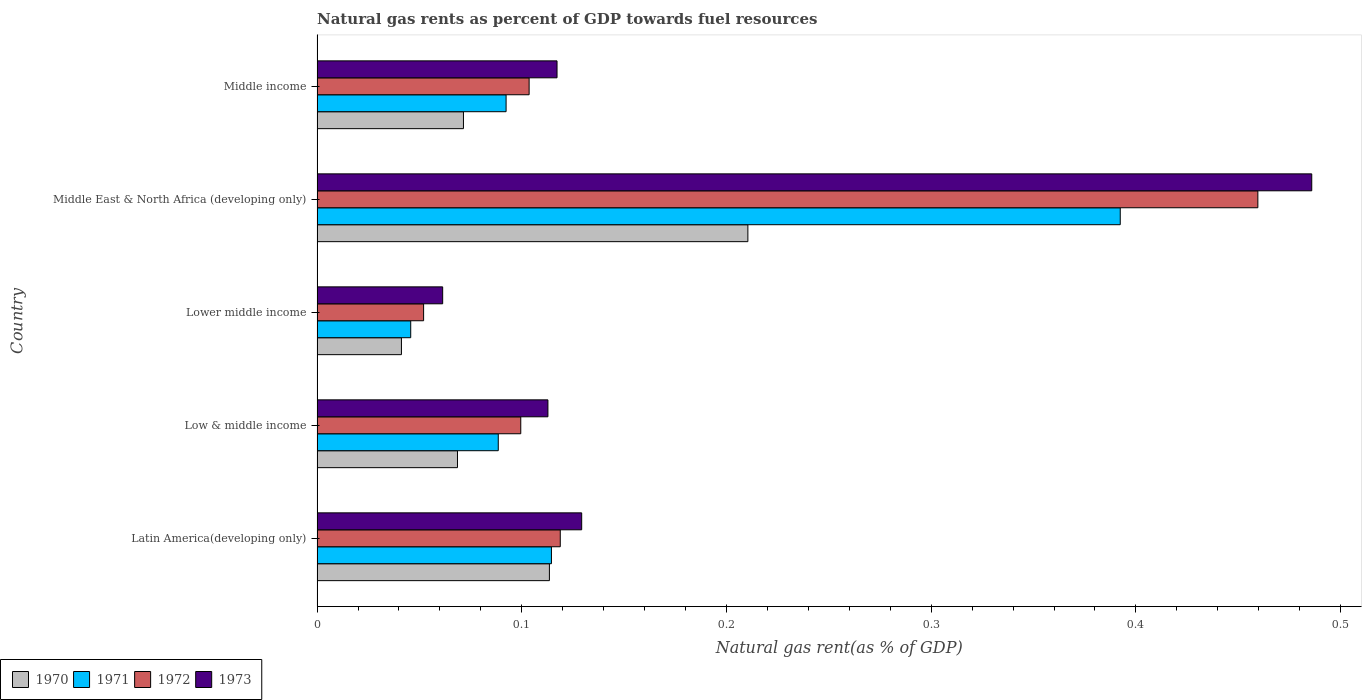How many different coloured bars are there?
Provide a succinct answer. 4. Are the number of bars per tick equal to the number of legend labels?
Make the answer very short. Yes. What is the label of the 2nd group of bars from the top?
Your answer should be compact. Middle East & North Africa (developing only). What is the natural gas rent in 1971 in Middle income?
Ensure brevity in your answer.  0.09. Across all countries, what is the maximum natural gas rent in 1972?
Your answer should be very brief. 0.46. Across all countries, what is the minimum natural gas rent in 1970?
Ensure brevity in your answer.  0.04. In which country was the natural gas rent in 1973 maximum?
Your answer should be compact. Middle East & North Africa (developing only). In which country was the natural gas rent in 1971 minimum?
Offer a terse response. Lower middle income. What is the total natural gas rent in 1973 in the graph?
Give a very brief answer. 0.91. What is the difference between the natural gas rent in 1972 in Latin America(developing only) and that in Lower middle income?
Make the answer very short. 0.07. What is the difference between the natural gas rent in 1973 in Lower middle income and the natural gas rent in 1972 in Low & middle income?
Provide a short and direct response. -0.04. What is the average natural gas rent in 1973 per country?
Provide a short and direct response. 0.18. What is the difference between the natural gas rent in 1972 and natural gas rent in 1971 in Low & middle income?
Provide a succinct answer. 0.01. In how many countries, is the natural gas rent in 1972 greater than 0.2 %?
Your answer should be very brief. 1. What is the ratio of the natural gas rent in 1972 in Middle East & North Africa (developing only) to that in Middle income?
Provide a succinct answer. 4.44. Is the difference between the natural gas rent in 1972 in Low & middle income and Middle income greater than the difference between the natural gas rent in 1971 in Low & middle income and Middle income?
Your answer should be compact. No. What is the difference between the highest and the second highest natural gas rent in 1971?
Make the answer very short. 0.28. What is the difference between the highest and the lowest natural gas rent in 1972?
Make the answer very short. 0.41. Is the sum of the natural gas rent in 1973 in Low & middle income and Middle income greater than the maximum natural gas rent in 1972 across all countries?
Provide a short and direct response. No. Is it the case that in every country, the sum of the natural gas rent in 1972 and natural gas rent in 1973 is greater than the sum of natural gas rent in 1970 and natural gas rent in 1971?
Ensure brevity in your answer.  No. What does the 4th bar from the top in Lower middle income represents?
Provide a short and direct response. 1970. Is it the case that in every country, the sum of the natural gas rent in 1973 and natural gas rent in 1970 is greater than the natural gas rent in 1972?
Your response must be concise. Yes. Are all the bars in the graph horizontal?
Ensure brevity in your answer.  Yes. Does the graph contain grids?
Give a very brief answer. No. What is the title of the graph?
Your answer should be very brief. Natural gas rents as percent of GDP towards fuel resources. Does "1962" appear as one of the legend labels in the graph?
Make the answer very short. No. What is the label or title of the X-axis?
Provide a short and direct response. Natural gas rent(as % of GDP). What is the label or title of the Y-axis?
Provide a succinct answer. Country. What is the Natural gas rent(as % of GDP) of 1970 in Latin America(developing only)?
Your response must be concise. 0.11. What is the Natural gas rent(as % of GDP) of 1971 in Latin America(developing only)?
Provide a short and direct response. 0.11. What is the Natural gas rent(as % of GDP) in 1972 in Latin America(developing only)?
Give a very brief answer. 0.12. What is the Natural gas rent(as % of GDP) of 1973 in Latin America(developing only)?
Provide a succinct answer. 0.13. What is the Natural gas rent(as % of GDP) of 1970 in Low & middle income?
Offer a very short reply. 0.07. What is the Natural gas rent(as % of GDP) of 1971 in Low & middle income?
Your answer should be very brief. 0.09. What is the Natural gas rent(as % of GDP) of 1972 in Low & middle income?
Provide a succinct answer. 0.1. What is the Natural gas rent(as % of GDP) in 1973 in Low & middle income?
Give a very brief answer. 0.11. What is the Natural gas rent(as % of GDP) in 1970 in Lower middle income?
Provide a succinct answer. 0.04. What is the Natural gas rent(as % of GDP) in 1971 in Lower middle income?
Keep it short and to the point. 0.05. What is the Natural gas rent(as % of GDP) of 1972 in Lower middle income?
Your answer should be very brief. 0.05. What is the Natural gas rent(as % of GDP) in 1973 in Lower middle income?
Your answer should be very brief. 0.06. What is the Natural gas rent(as % of GDP) of 1970 in Middle East & North Africa (developing only)?
Offer a very short reply. 0.21. What is the Natural gas rent(as % of GDP) in 1971 in Middle East & North Africa (developing only)?
Offer a terse response. 0.39. What is the Natural gas rent(as % of GDP) in 1972 in Middle East & North Africa (developing only)?
Your answer should be compact. 0.46. What is the Natural gas rent(as % of GDP) of 1973 in Middle East & North Africa (developing only)?
Your answer should be compact. 0.49. What is the Natural gas rent(as % of GDP) of 1970 in Middle income?
Provide a succinct answer. 0.07. What is the Natural gas rent(as % of GDP) of 1971 in Middle income?
Provide a short and direct response. 0.09. What is the Natural gas rent(as % of GDP) in 1972 in Middle income?
Your answer should be very brief. 0.1. What is the Natural gas rent(as % of GDP) in 1973 in Middle income?
Offer a terse response. 0.12. Across all countries, what is the maximum Natural gas rent(as % of GDP) of 1970?
Provide a short and direct response. 0.21. Across all countries, what is the maximum Natural gas rent(as % of GDP) in 1971?
Provide a short and direct response. 0.39. Across all countries, what is the maximum Natural gas rent(as % of GDP) in 1972?
Keep it short and to the point. 0.46. Across all countries, what is the maximum Natural gas rent(as % of GDP) in 1973?
Ensure brevity in your answer.  0.49. Across all countries, what is the minimum Natural gas rent(as % of GDP) of 1970?
Offer a terse response. 0.04. Across all countries, what is the minimum Natural gas rent(as % of GDP) of 1971?
Offer a very short reply. 0.05. Across all countries, what is the minimum Natural gas rent(as % of GDP) in 1972?
Make the answer very short. 0.05. Across all countries, what is the minimum Natural gas rent(as % of GDP) of 1973?
Give a very brief answer. 0.06. What is the total Natural gas rent(as % of GDP) of 1970 in the graph?
Keep it short and to the point. 0.51. What is the total Natural gas rent(as % of GDP) in 1971 in the graph?
Keep it short and to the point. 0.73. What is the total Natural gas rent(as % of GDP) in 1972 in the graph?
Your answer should be compact. 0.83. What is the total Natural gas rent(as % of GDP) in 1973 in the graph?
Make the answer very short. 0.91. What is the difference between the Natural gas rent(as % of GDP) in 1970 in Latin America(developing only) and that in Low & middle income?
Make the answer very short. 0.04. What is the difference between the Natural gas rent(as % of GDP) in 1971 in Latin America(developing only) and that in Low & middle income?
Keep it short and to the point. 0.03. What is the difference between the Natural gas rent(as % of GDP) of 1972 in Latin America(developing only) and that in Low & middle income?
Your response must be concise. 0.02. What is the difference between the Natural gas rent(as % of GDP) of 1973 in Latin America(developing only) and that in Low & middle income?
Your answer should be very brief. 0.02. What is the difference between the Natural gas rent(as % of GDP) of 1970 in Latin America(developing only) and that in Lower middle income?
Your response must be concise. 0.07. What is the difference between the Natural gas rent(as % of GDP) in 1971 in Latin America(developing only) and that in Lower middle income?
Your answer should be very brief. 0.07. What is the difference between the Natural gas rent(as % of GDP) in 1972 in Latin America(developing only) and that in Lower middle income?
Offer a very short reply. 0.07. What is the difference between the Natural gas rent(as % of GDP) in 1973 in Latin America(developing only) and that in Lower middle income?
Give a very brief answer. 0.07. What is the difference between the Natural gas rent(as % of GDP) in 1970 in Latin America(developing only) and that in Middle East & North Africa (developing only)?
Offer a very short reply. -0.1. What is the difference between the Natural gas rent(as % of GDP) of 1971 in Latin America(developing only) and that in Middle East & North Africa (developing only)?
Offer a terse response. -0.28. What is the difference between the Natural gas rent(as % of GDP) of 1972 in Latin America(developing only) and that in Middle East & North Africa (developing only)?
Your response must be concise. -0.34. What is the difference between the Natural gas rent(as % of GDP) of 1973 in Latin America(developing only) and that in Middle East & North Africa (developing only)?
Your answer should be very brief. -0.36. What is the difference between the Natural gas rent(as % of GDP) of 1970 in Latin America(developing only) and that in Middle income?
Your response must be concise. 0.04. What is the difference between the Natural gas rent(as % of GDP) of 1971 in Latin America(developing only) and that in Middle income?
Your response must be concise. 0.02. What is the difference between the Natural gas rent(as % of GDP) of 1972 in Latin America(developing only) and that in Middle income?
Provide a short and direct response. 0.02. What is the difference between the Natural gas rent(as % of GDP) of 1973 in Latin America(developing only) and that in Middle income?
Give a very brief answer. 0.01. What is the difference between the Natural gas rent(as % of GDP) in 1970 in Low & middle income and that in Lower middle income?
Ensure brevity in your answer.  0.03. What is the difference between the Natural gas rent(as % of GDP) of 1971 in Low & middle income and that in Lower middle income?
Your response must be concise. 0.04. What is the difference between the Natural gas rent(as % of GDP) in 1972 in Low & middle income and that in Lower middle income?
Offer a terse response. 0.05. What is the difference between the Natural gas rent(as % of GDP) of 1973 in Low & middle income and that in Lower middle income?
Ensure brevity in your answer.  0.05. What is the difference between the Natural gas rent(as % of GDP) in 1970 in Low & middle income and that in Middle East & North Africa (developing only)?
Keep it short and to the point. -0.14. What is the difference between the Natural gas rent(as % of GDP) of 1971 in Low & middle income and that in Middle East & North Africa (developing only)?
Make the answer very short. -0.3. What is the difference between the Natural gas rent(as % of GDP) in 1972 in Low & middle income and that in Middle East & North Africa (developing only)?
Ensure brevity in your answer.  -0.36. What is the difference between the Natural gas rent(as % of GDP) of 1973 in Low & middle income and that in Middle East & North Africa (developing only)?
Offer a very short reply. -0.37. What is the difference between the Natural gas rent(as % of GDP) in 1970 in Low & middle income and that in Middle income?
Offer a terse response. -0. What is the difference between the Natural gas rent(as % of GDP) in 1971 in Low & middle income and that in Middle income?
Your answer should be very brief. -0. What is the difference between the Natural gas rent(as % of GDP) in 1972 in Low & middle income and that in Middle income?
Provide a short and direct response. -0. What is the difference between the Natural gas rent(as % of GDP) of 1973 in Low & middle income and that in Middle income?
Make the answer very short. -0. What is the difference between the Natural gas rent(as % of GDP) of 1970 in Lower middle income and that in Middle East & North Africa (developing only)?
Keep it short and to the point. -0.17. What is the difference between the Natural gas rent(as % of GDP) of 1971 in Lower middle income and that in Middle East & North Africa (developing only)?
Keep it short and to the point. -0.35. What is the difference between the Natural gas rent(as % of GDP) in 1972 in Lower middle income and that in Middle East & North Africa (developing only)?
Provide a succinct answer. -0.41. What is the difference between the Natural gas rent(as % of GDP) in 1973 in Lower middle income and that in Middle East & North Africa (developing only)?
Provide a short and direct response. -0.42. What is the difference between the Natural gas rent(as % of GDP) of 1970 in Lower middle income and that in Middle income?
Provide a short and direct response. -0.03. What is the difference between the Natural gas rent(as % of GDP) of 1971 in Lower middle income and that in Middle income?
Give a very brief answer. -0.05. What is the difference between the Natural gas rent(as % of GDP) of 1972 in Lower middle income and that in Middle income?
Give a very brief answer. -0.05. What is the difference between the Natural gas rent(as % of GDP) of 1973 in Lower middle income and that in Middle income?
Ensure brevity in your answer.  -0.06. What is the difference between the Natural gas rent(as % of GDP) of 1970 in Middle East & North Africa (developing only) and that in Middle income?
Offer a very short reply. 0.14. What is the difference between the Natural gas rent(as % of GDP) in 1972 in Middle East & North Africa (developing only) and that in Middle income?
Provide a succinct answer. 0.36. What is the difference between the Natural gas rent(as % of GDP) in 1973 in Middle East & North Africa (developing only) and that in Middle income?
Your answer should be compact. 0.37. What is the difference between the Natural gas rent(as % of GDP) in 1970 in Latin America(developing only) and the Natural gas rent(as % of GDP) in 1971 in Low & middle income?
Make the answer very short. 0.03. What is the difference between the Natural gas rent(as % of GDP) in 1970 in Latin America(developing only) and the Natural gas rent(as % of GDP) in 1972 in Low & middle income?
Offer a very short reply. 0.01. What is the difference between the Natural gas rent(as % of GDP) in 1970 in Latin America(developing only) and the Natural gas rent(as % of GDP) in 1973 in Low & middle income?
Offer a terse response. 0. What is the difference between the Natural gas rent(as % of GDP) in 1971 in Latin America(developing only) and the Natural gas rent(as % of GDP) in 1972 in Low & middle income?
Give a very brief answer. 0.01. What is the difference between the Natural gas rent(as % of GDP) in 1971 in Latin America(developing only) and the Natural gas rent(as % of GDP) in 1973 in Low & middle income?
Keep it short and to the point. 0. What is the difference between the Natural gas rent(as % of GDP) in 1972 in Latin America(developing only) and the Natural gas rent(as % of GDP) in 1973 in Low & middle income?
Your answer should be very brief. 0.01. What is the difference between the Natural gas rent(as % of GDP) of 1970 in Latin America(developing only) and the Natural gas rent(as % of GDP) of 1971 in Lower middle income?
Offer a terse response. 0.07. What is the difference between the Natural gas rent(as % of GDP) in 1970 in Latin America(developing only) and the Natural gas rent(as % of GDP) in 1972 in Lower middle income?
Your answer should be compact. 0.06. What is the difference between the Natural gas rent(as % of GDP) in 1970 in Latin America(developing only) and the Natural gas rent(as % of GDP) in 1973 in Lower middle income?
Provide a succinct answer. 0.05. What is the difference between the Natural gas rent(as % of GDP) in 1971 in Latin America(developing only) and the Natural gas rent(as % of GDP) in 1972 in Lower middle income?
Your answer should be very brief. 0.06. What is the difference between the Natural gas rent(as % of GDP) in 1971 in Latin America(developing only) and the Natural gas rent(as % of GDP) in 1973 in Lower middle income?
Your answer should be very brief. 0.05. What is the difference between the Natural gas rent(as % of GDP) in 1972 in Latin America(developing only) and the Natural gas rent(as % of GDP) in 1973 in Lower middle income?
Give a very brief answer. 0.06. What is the difference between the Natural gas rent(as % of GDP) in 1970 in Latin America(developing only) and the Natural gas rent(as % of GDP) in 1971 in Middle East & North Africa (developing only)?
Your response must be concise. -0.28. What is the difference between the Natural gas rent(as % of GDP) in 1970 in Latin America(developing only) and the Natural gas rent(as % of GDP) in 1972 in Middle East & North Africa (developing only)?
Provide a short and direct response. -0.35. What is the difference between the Natural gas rent(as % of GDP) in 1970 in Latin America(developing only) and the Natural gas rent(as % of GDP) in 1973 in Middle East & North Africa (developing only)?
Provide a succinct answer. -0.37. What is the difference between the Natural gas rent(as % of GDP) of 1971 in Latin America(developing only) and the Natural gas rent(as % of GDP) of 1972 in Middle East & North Africa (developing only)?
Keep it short and to the point. -0.35. What is the difference between the Natural gas rent(as % of GDP) in 1971 in Latin America(developing only) and the Natural gas rent(as % of GDP) in 1973 in Middle East & North Africa (developing only)?
Keep it short and to the point. -0.37. What is the difference between the Natural gas rent(as % of GDP) of 1972 in Latin America(developing only) and the Natural gas rent(as % of GDP) of 1973 in Middle East & North Africa (developing only)?
Ensure brevity in your answer.  -0.37. What is the difference between the Natural gas rent(as % of GDP) of 1970 in Latin America(developing only) and the Natural gas rent(as % of GDP) of 1971 in Middle income?
Provide a short and direct response. 0.02. What is the difference between the Natural gas rent(as % of GDP) in 1970 in Latin America(developing only) and the Natural gas rent(as % of GDP) in 1972 in Middle income?
Offer a very short reply. 0.01. What is the difference between the Natural gas rent(as % of GDP) in 1970 in Latin America(developing only) and the Natural gas rent(as % of GDP) in 1973 in Middle income?
Give a very brief answer. -0. What is the difference between the Natural gas rent(as % of GDP) in 1971 in Latin America(developing only) and the Natural gas rent(as % of GDP) in 1972 in Middle income?
Provide a succinct answer. 0.01. What is the difference between the Natural gas rent(as % of GDP) of 1971 in Latin America(developing only) and the Natural gas rent(as % of GDP) of 1973 in Middle income?
Offer a very short reply. -0. What is the difference between the Natural gas rent(as % of GDP) of 1972 in Latin America(developing only) and the Natural gas rent(as % of GDP) of 1973 in Middle income?
Offer a very short reply. 0. What is the difference between the Natural gas rent(as % of GDP) of 1970 in Low & middle income and the Natural gas rent(as % of GDP) of 1971 in Lower middle income?
Ensure brevity in your answer.  0.02. What is the difference between the Natural gas rent(as % of GDP) in 1970 in Low & middle income and the Natural gas rent(as % of GDP) in 1972 in Lower middle income?
Provide a short and direct response. 0.02. What is the difference between the Natural gas rent(as % of GDP) of 1970 in Low & middle income and the Natural gas rent(as % of GDP) of 1973 in Lower middle income?
Give a very brief answer. 0.01. What is the difference between the Natural gas rent(as % of GDP) in 1971 in Low & middle income and the Natural gas rent(as % of GDP) in 1972 in Lower middle income?
Keep it short and to the point. 0.04. What is the difference between the Natural gas rent(as % of GDP) of 1971 in Low & middle income and the Natural gas rent(as % of GDP) of 1973 in Lower middle income?
Your response must be concise. 0.03. What is the difference between the Natural gas rent(as % of GDP) in 1972 in Low & middle income and the Natural gas rent(as % of GDP) in 1973 in Lower middle income?
Offer a very short reply. 0.04. What is the difference between the Natural gas rent(as % of GDP) in 1970 in Low & middle income and the Natural gas rent(as % of GDP) in 1971 in Middle East & North Africa (developing only)?
Offer a very short reply. -0.32. What is the difference between the Natural gas rent(as % of GDP) of 1970 in Low & middle income and the Natural gas rent(as % of GDP) of 1972 in Middle East & North Africa (developing only)?
Offer a terse response. -0.39. What is the difference between the Natural gas rent(as % of GDP) in 1970 in Low & middle income and the Natural gas rent(as % of GDP) in 1973 in Middle East & North Africa (developing only)?
Ensure brevity in your answer.  -0.42. What is the difference between the Natural gas rent(as % of GDP) of 1971 in Low & middle income and the Natural gas rent(as % of GDP) of 1972 in Middle East & North Africa (developing only)?
Your response must be concise. -0.37. What is the difference between the Natural gas rent(as % of GDP) in 1971 in Low & middle income and the Natural gas rent(as % of GDP) in 1973 in Middle East & North Africa (developing only)?
Make the answer very short. -0.4. What is the difference between the Natural gas rent(as % of GDP) in 1972 in Low & middle income and the Natural gas rent(as % of GDP) in 1973 in Middle East & North Africa (developing only)?
Offer a very short reply. -0.39. What is the difference between the Natural gas rent(as % of GDP) of 1970 in Low & middle income and the Natural gas rent(as % of GDP) of 1971 in Middle income?
Give a very brief answer. -0.02. What is the difference between the Natural gas rent(as % of GDP) in 1970 in Low & middle income and the Natural gas rent(as % of GDP) in 1972 in Middle income?
Ensure brevity in your answer.  -0.04. What is the difference between the Natural gas rent(as % of GDP) in 1970 in Low & middle income and the Natural gas rent(as % of GDP) in 1973 in Middle income?
Make the answer very short. -0.05. What is the difference between the Natural gas rent(as % of GDP) in 1971 in Low & middle income and the Natural gas rent(as % of GDP) in 1972 in Middle income?
Offer a terse response. -0.02. What is the difference between the Natural gas rent(as % of GDP) in 1971 in Low & middle income and the Natural gas rent(as % of GDP) in 1973 in Middle income?
Provide a short and direct response. -0.03. What is the difference between the Natural gas rent(as % of GDP) of 1972 in Low & middle income and the Natural gas rent(as % of GDP) of 1973 in Middle income?
Give a very brief answer. -0.02. What is the difference between the Natural gas rent(as % of GDP) in 1970 in Lower middle income and the Natural gas rent(as % of GDP) in 1971 in Middle East & North Africa (developing only)?
Your answer should be very brief. -0.35. What is the difference between the Natural gas rent(as % of GDP) in 1970 in Lower middle income and the Natural gas rent(as % of GDP) in 1972 in Middle East & North Africa (developing only)?
Provide a short and direct response. -0.42. What is the difference between the Natural gas rent(as % of GDP) of 1970 in Lower middle income and the Natural gas rent(as % of GDP) of 1973 in Middle East & North Africa (developing only)?
Offer a very short reply. -0.44. What is the difference between the Natural gas rent(as % of GDP) in 1971 in Lower middle income and the Natural gas rent(as % of GDP) in 1972 in Middle East & North Africa (developing only)?
Give a very brief answer. -0.41. What is the difference between the Natural gas rent(as % of GDP) in 1971 in Lower middle income and the Natural gas rent(as % of GDP) in 1973 in Middle East & North Africa (developing only)?
Your response must be concise. -0.44. What is the difference between the Natural gas rent(as % of GDP) in 1972 in Lower middle income and the Natural gas rent(as % of GDP) in 1973 in Middle East & North Africa (developing only)?
Your answer should be compact. -0.43. What is the difference between the Natural gas rent(as % of GDP) in 1970 in Lower middle income and the Natural gas rent(as % of GDP) in 1971 in Middle income?
Provide a short and direct response. -0.05. What is the difference between the Natural gas rent(as % of GDP) of 1970 in Lower middle income and the Natural gas rent(as % of GDP) of 1972 in Middle income?
Your answer should be very brief. -0.06. What is the difference between the Natural gas rent(as % of GDP) in 1970 in Lower middle income and the Natural gas rent(as % of GDP) in 1973 in Middle income?
Your answer should be compact. -0.08. What is the difference between the Natural gas rent(as % of GDP) in 1971 in Lower middle income and the Natural gas rent(as % of GDP) in 1972 in Middle income?
Provide a succinct answer. -0.06. What is the difference between the Natural gas rent(as % of GDP) of 1971 in Lower middle income and the Natural gas rent(as % of GDP) of 1973 in Middle income?
Make the answer very short. -0.07. What is the difference between the Natural gas rent(as % of GDP) in 1972 in Lower middle income and the Natural gas rent(as % of GDP) in 1973 in Middle income?
Give a very brief answer. -0.07. What is the difference between the Natural gas rent(as % of GDP) in 1970 in Middle East & North Africa (developing only) and the Natural gas rent(as % of GDP) in 1971 in Middle income?
Your answer should be very brief. 0.12. What is the difference between the Natural gas rent(as % of GDP) of 1970 in Middle East & North Africa (developing only) and the Natural gas rent(as % of GDP) of 1972 in Middle income?
Provide a succinct answer. 0.11. What is the difference between the Natural gas rent(as % of GDP) in 1970 in Middle East & North Africa (developing only) and the Natural gas rent(as % of GDP) in 1973 in Middle income?
Give a very brief answer. 0.09. What is the difference between the Natural gas rent(as % of GDP) of 1971 in Middle East & North Africa (developing only) and the Natural gas rent(as % of GDP) of 1972 in Middle income?
Give a very brief answer. 0.29. What is the difference between the Natural gas rent(as % of GDP) of 1971 in Middle East & North Africa (developing only) and the Natural gas rent(as % of GDP) of 1973 in Middle income?
Offer a very short reply. 0.28. What is the difference between the Natural gas rent(as % of GDP) in 1972 in Middle East & North Africa (developing only) and the Natural gas rent(as % of GDP) in 1973 in Middle income?
Your answer should be compact. 0.34. What is the average Natural gas rent(as % of GDP) of 1970 per country?
Offer a very short reply. 0.1. What is the average Natural gas rent(as % of GDP) in 1971 per country?
Provide a succinct answer. 0.15. What is the average Natural gas rent(as % of GDP) in 1972 per country?
Your answer should be very brief. 0.17. What is the average Natural gas rent(as % of GDP) in 1973 per country?
Keep it short and to the point. 0.18. What is the difference between the Natural gas rent(as % of GDP) in 1970 and Natural gas rent(as % of GDP) in 1971 in Latin America(developing only)?
Provide a short and direct response. -0. What is the difference between the Natural gas rent(as % of GDP) in 1970 and Natural gas rent(as % of GDP) in 1972 in Latin America(developing only)?
Keep it short and to the point. -0.01. What is the difference between the Natural gas rent(as % of GDP) in 1970 and Natural gas rent(as % of GDP) in 1973 in Latin America(developing only)?
Make the answer very short. -0.02. What is the difference between the Natural gas rent(as % of GDP) of 1971 and Natural gas rent(as % of GDP) of 1972 in Latin America(developing only)?
Your answer should be very brief. -0. What is the difference between the Natural gas rent(as % of GDP) of 1971 and Natural gas rent(as % of GDP) of 1973 in Latin America(developing only)?
Give a very brief answer. -0.01. What is the difference between the Natural gas rent(as % of GDP) in 1972 and Natural gas rent(as % of GDP) in 1973 in Latin America(developing only)?
Give a very brief answer. -0.01. What is the difference between the Natural gas rent(as % of GDP) in 1970 and Natural gas rent(as % of GDP) in 1971 in Low & middle income?
Provide a succinct answer. -0.02. What is the difference between the Natural gas rent(as % of GDP) in 1970 and Natural gas rent(as % of GDP) in 1972 in Low & middle income?
Make the answer very short. -0.03. What is the difference between the Natural gas rent(as % of GDP) of 1970 and Natural gas rent(as % of GDP) of 1973 in Low & middle income?
Your response must be concise. -0.04. What is the difference between the Natural gas rent(as % of GDP) of 1971 and Natural gas rent(as % of GDP) of 1972 in Low & middle income?
Your answer should be compact. -0.01. What is the difference between the Natural gas rent(as % of GDP) in 1971 and Natural gas rent(as % of GDP) in 1973 in Low & middle income?
Keep it short and to the point. -0.02. What is the difference between the Natural gas rent(as % of GDP) in 1972 and Natural gas rent(as % of GDP) in 1973 in Low & middle income?
Provide a succinct answer. -0.01. What is the difference between the Natural gas rent(as % of GDP) of 1970 and Natural gas rent(as % of GDP) of 1971 in Lower middle income?
Your answer should be very brief. -0. What is the difference between the Natural gas rent(as % of GDP) in 1970 and Natural gas rent(as % of GDP) in 1972 in Lower middle income?
Offer a terse response. -0.01. What is the difference between the Natural gas rent(as % of GDP) of 1970 and Natural gas rent(as % of GDP) of 1973 in Lower middle income?
Give a very brief answer. -0.02. What is the difference between the Natural gas rent(as % of GDP) in 1971 and Natural gas rent(as % of GDP) in 1972 in Lower middle income?
Your answer should be very brief. -0.01. What is the difference between the Natural gas rent(as % of GDP) in 1971 and Natural gas rent(as % of GDP) in 1973 in Lower middle income?
Ensure brevity in your answer.  -0.02. What is the difference between the Natural gas rent(as % of GDP) in 1972 and Natural gas rent(as % of GDP) in 1973 in Lower middle income?
Give a very brief answer. -0.01. What is the difference between the Natural gas rent(as % of GDP) of 1970 and Natural gas rent(as % of GDP) of 1971 in Middle East & North Africa (developing only)?
Ensure brevity in your answer.  -0.18. What is the difference between the Natural gas rent(as % of GDP) of 1970 and Natural gas rent(as % of GDP) of 1972 in Middle East & North Africa (developing only)?
Provide a short and direct response. -0.25. What is the difference between the Natural gas rent(as % of GDP) of 1970 and Natural gas rent(as % of GDP) of 1973 in Middle East & North Africa (developing only)?
Give a very brief answer. -0.28. What is the difference between the Natural gas rent(as % of GDP) of 1971 and Natural gas rent(as % of GDP) of 1972 in Middle East & North Africa (developing only)?
Keep it short and to the point. -0.07. What is the difference between the Natural gas rent(as % of GDP) of 1971 and Natural gas rent(as % of GDP) of 1973 in Middle East & North Africa (developing only)?
Your response must be concise. -0.09. What is the difference between the Natural gas rent(as % of GDP) in 1972 and Natural gas rent(as % of GDP) in 1973 in Middle East & North Africa (developing only)?
Offer a very short reply. -0.03. What is the difference between the Natural gas rent(as % of GDP) of 1970 and Natural gas rent(as % of GDP) of 1971 in Middle income?
Your answer should be very brief. -0.02. What is the difference between the Natural gas rent(as % of GDP) of 1970 and Natural gas rent(as % of GDP) of 1972 in Middle income?
Ensure brevity in your answer.  -0.03. What is the difference between the Natural gas rent(as % of GDP) in 1970 and Natural gas rent(as % of GDP) in 1973 in Middle income?
Your response must be concise. -0.05. What is the difference between the Natural gas rent(as % of GDP) of 1971 and Natural gas rent(as % of GDP) of 1972 in Middle income?
Provide a short and direct response. -0.01. What is the difference between the Natural gas rent(as % of GDP) of 1971 and Natural gas rent(as % of GDP) of 1973 in Middle income?
Your answer should be very brief. -0.02. What is the difference between the Natural gas rent(as % of GDP) of 1972 and Natural gas rent(as % of GDP) of 1973 in Middle income?
Provide a succinct answer. -0.01. What is the ratio of the Natural gas rent(as % of GDP) in 1970 in Latin America(developing only) to that in Low & middle income?
Your response must be concise. 1.65. What is the ratio of the Natural gas rent(as % of GDP) of 1971 in Latin America(developing only) to that in Low & middle income?
Your answer should be very brief. 1.29. What is the ratio of the Natural gas rent(as % of GDP) in 1972 in Latin America(developing only) to that in Low & middle income?
Make the answer very short. 1.19. What is the ratio of the Natural gas rent(as % of GDP) of 1973 in Latin America(developing only) to that in Low & middle income?
Make the answer very short. 1.15. What is the ratio of the Natural gas rent(as % of GDP) of 1970 in Latin America(developing only) to that in Lower middle income?
Provide a short and direct response. 2.75. What is the ratio of the Natural gas rent(as % of GDP) of 1971 in Latin America(developing only) to that in Lower middle income?
Ensure brevity in your answer.  2.5. What is the ratio of the Natural gas rent(as % of GDP) in 1972 in Latin America(developing only) to that in Lower middle income?
Provide a succinct answer. 2.28. What is the ratio of the Natural gas rent(as % of GDP) of 1973 in Latin America(developing only) to that in Lower middle income?
Keep it short and to the point. 2.11. What is the ratio of the Natural gas rent(as % of GDP) in 1970 in Latin America(developing only) to that in Middle East & North Africa (developing only)?
Keep it short and to the point. 0.54. What is the ratio of the Natural gas rent(as % of GDP) in 1971 in Latin America(developing only) to that in Middle East & North Africa (developing only)?
Your answer should be very brief. 0.29. What is the ratio of the Natural gas rent(as % of GDP) in 1972 in Latin America(developing only) to that in Middle East & North Africa (developing only)?
Provide a succinct answer. 0.26. What is the ratio of the Natural gas rent(as % of GDP) in 1973 in Latin America(developing only) to that in Middle East & North Africa (developing only)?
Make the answer very short. 0.27. What is the ratio of the Natural gas rent(as % of GDP) in 1970 in Latin America(developing only) to that in Middle income?
Offer a very short reply. 1.59. What is the ratio of the Natural gas rent(as % of GDP) in 1971 in Latin America(developing only) to that in Middle income?
Provide a succinct answer. 1.24. What is the ratio of the Natural gas rent(as % of GDP) of 1972 in Latin America(developing only) to that in Middle income?
Your response must be concise. 1.15. What is the ratio of the Natural gas rent(as % of GDP) in 1973 in Latin America(developing only) to that in Middle income?
Offer a terse response. 1.1. What is the ratio of the Natural gas rent(as % of GDP) in 1970 in Low & middle income to that in Lower middle income?
Your answer should be very brief. 1.66. What is the ratio of the Natural gas rent(as % of GDP) in 1971 in Low & middle income to that in Lower middle income?
Give a very brief answer. 1.93. What is the ratio of the Natural gas rent(as % of GDP) of 1972 in Low & middle income to that in Lower middle income?
Make the answer very short. 1.91. What is the ratio of the Natural gas rent(as % of GDP) of 1973 in Low & middle income to that in Lower middle income?
Provide a succinct answer. 1.84. What is the ratio of the Natural gas rent(as % of GDP) in 1970 in Low & middle income to that in Middle East & North Africa (developing only)?
Offer a terse response. 0.33. What is the ratio of the Natural gas rent(as % of GDP) in 1971 in Low & middle income to that in Middle East & North Africa (developing only)?
Your response must be concise. 0.23. What is the ratio of the Natural gas rent(as % of GDP) of 1972 in Low & middle income to that in Middle East & North Africa (developing only)?
Your response must be concise. 0.22. What is the ratio of the Natural gas rent(as % of GDP) of 1973 in Low & middle income to that in Middle East & North Africa (developing only)?
Give a very brief answer. 0.23. What is the ratio of the Natural gas rent(as % of GDP) in 1970 in Low & middle income to that in Middle income?
Offer a very short reply. 0.96. What is the ratio of the Natural gas rent(as % of GDP) in 1971 in Low & middle income to that in Middle income?
Ensure brevity in your answer.  0.96. What is the ratio of the Natural gas rent(as % of GDP) in 1972 in Low & middle income to that in Middle income?
Provide a succinct answer. 0.96. What is the ratio of the Natural gas rent(as % of GDP) in 1973 in Low & middle income to that in Middle income?
Offer a terse response. 0.96. What is the ratio of the Natural gas rent(as % of GDP) in 1970 in Lower middle income to that in Middle East & North Africa (developing only)?
Keep it short and to the point. 0.2. What is the ratio of the Natural gas rent(as % of GDP) in 1971 in Lower middle income to that in Middle East & North Africa (developing only)?
Make the answer very short. 0.12. What is the ratio of the Natural gas rent(as % of GDP) in 1972 in Lower middle income to that in Middle East & North Africa (developing only)?
Your answer should be compact. 0.11. What is the ratio of the Natural gas rent(as % of GDP) of 1973 in Lower middle income to that in Middle East & North Africa (developing only)?
Ensure brevity in your answer.  0.13. What is the ratio of the Natural gas rent(as % of GDP) in 1970 in Lower middle income to that in Middle income?
Give a very brief answer. 0.58. What is the ratio of the Natural gas rent(as % of GDP) in 1971 in Lower middle income to that in Middle income?
Offer a terse response. 0.5. What is the ratio of the Natural gas rent(as % of GDP) of 1972 in Lower middle income to that in Middle income?
Offer a very short reply. 0.5. What is the ratio of the Natural gas rent(as % of GDP) of 1973 in Lower middle income to that in Middle income?
Your answer should be compact. 0.52. What is the ratio of the Natural gas rent(as % of GDP) in 1970 in Middle East & North Africa (developing only) to that in Middle income?
Ensure brevity in your answer.  2.94. What is the ratio of the Natural gas rent(as % of GDP) of 1971 in Middle East & North Africa (developing only) to that in Middle income?
Offer a very short reply. 4.25. What is the ratio of the Natural gas rent(as % of GDP) of 1972 in Middle East & North Africa (developing only) to that in Middle income?
Give a very brief answer. 4.44. What is the ratio of the Natural gas rent(as % of GDP) in 1973 in Middle East & North Africa (developing only) to that in Middle income?
Your response must be concise. 4.14. What is the difference between the highest and the second highest Natural gas rent(as % of GDP) in 1970?
Your answer should be very brief. 0.1. What is the difference between the highest and the second highest Natural gas rent(as % of GDP) of 1971?
Keep it short and to the point. 0.28. What is the difference between the highest and the second highest Natural gas rent(as % of GDP) of 1972?
Your answer should be very brief. 0.34. What is the difference between the highest and the second highest Natural gas rent(as % of GDP) in 1973?
Your answer should be compact. 0.36. What is the difference between the highest and the lowest Natural gas rent(as % of GDP) in 1970?
Give a very brief answer. 0.17. What is the difference between the highest and the lowest Natural gas rent(as % of GDP) of 1971?
Keep it short and to the point. 0.35. What is the difference between the highest and the lowest Natural gas rent(as % of GDP) of 1972?
Give a very brief answer. 0.41. What is the difference between the highest and the lowest Natural gas rent(as % of GDP) of 1973?
Your answer should be compact. 0.42. 